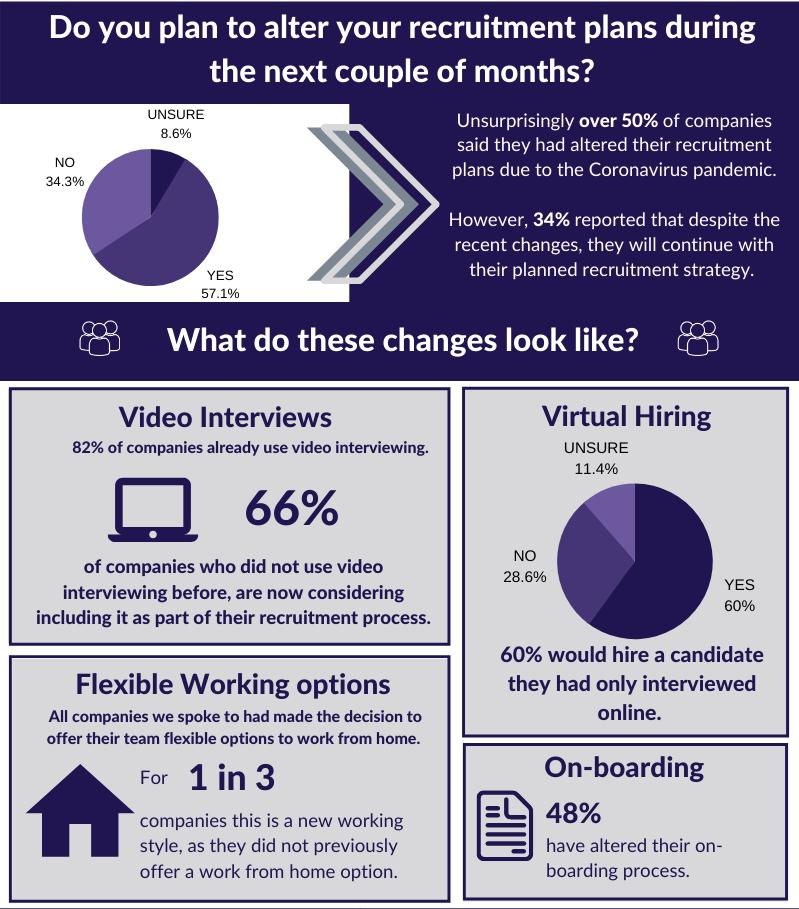Give some essential details in this illustration. According to the data, a significant percentage of businesses have not yet made a decision to hire or not. The inverse percentage of businesses who have not decided yet to hire or not is 91.4%. It is estimated that a significant proportion of companies promoted the practice of working from home before the pandemic, with some sources indicating that the number could be as high as three out of every four companies. A recent survey has revealed that 57.1% of businesses have changed their desire for hiring new employees. Prior to the pandemic, 82% of companies were following online hiring practices. According to the information, 66% of companies are new to the online hiring procedure. 